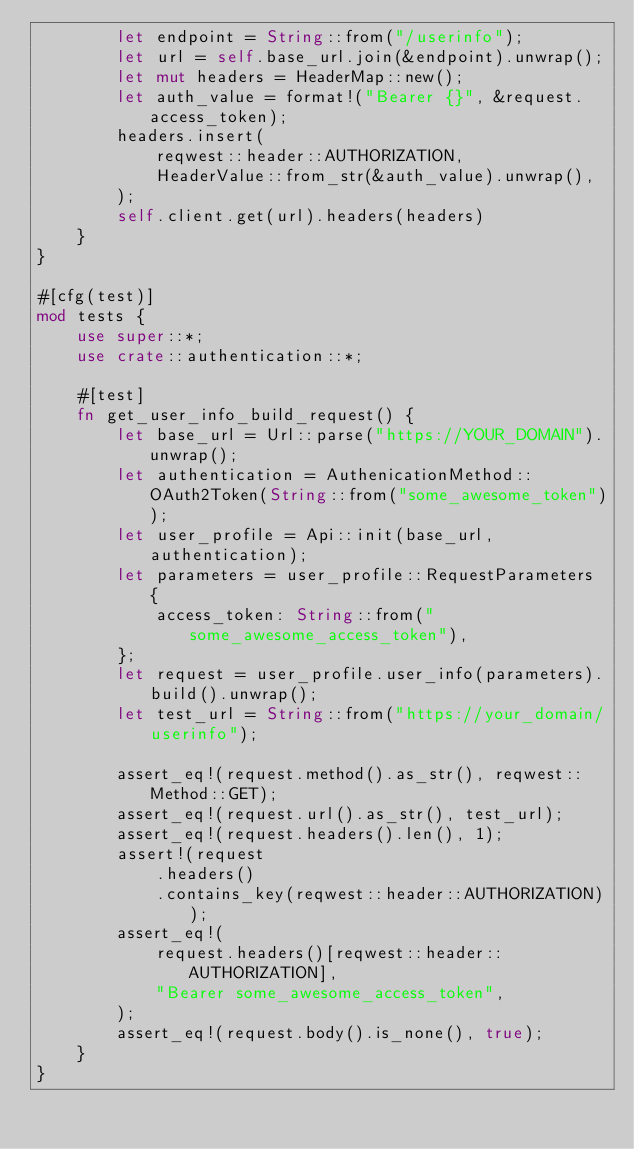Convert code to text. <code><loc_0><loc_0><loc_500><loc_500><_Rust_>        let endpoint = String::from("/userinfo");
        let url = self.base_url.join(&endpoint).unwrap();
        let mut headers = HeaderMap::new();
        let auth_value = format!("Bearer {}", &request.access_token);
        headers.insert(
            reqwest::header::AUTHORIZATION,
            HeaderValue::from_str(&auth_value).unwrap(),
        );
        self.client.get(url).headers(headers)
    }
}

#[cfg(test)]
mod tests {
    use super::*;
    use crate::authentication::*;

    #[test]
    fn get_user_info_build_request() {
        let base_url = Url::parse("https://YOUR_DOMAIN").unwrap();
        let authentication = AuthenicationMethod::OAuth2Token(String::from("some_awesome_token"));
        let user_profile = Api::init(base_url, authentication);
        let parameters = user_profile::RequestParameters {
            access_token: String::from("some_awesome_access_token"),
        };
        let request = user_profile.user_info(parameters).build().unwrap();
        let test_url = String::from("https://your_domain/userinfo");

        assert_eq!(request.method().as_str(), reqwest::Method::GET);
        assert_eq!(request.url().as_str(), test_url);
        assert_eq!(request.headers().len(), 1);
        assert!(request
            .headers()
            .contains_key(reqwest::header::AUTHORIZATION));
        assert_eq!(
            request.headers()[reqwest::header::AUTHORIZATION],
            "Bearer some_awesome_access_token",
        );
        assert_eq!(request.body().is_none(), true);
    }
}
</code> 